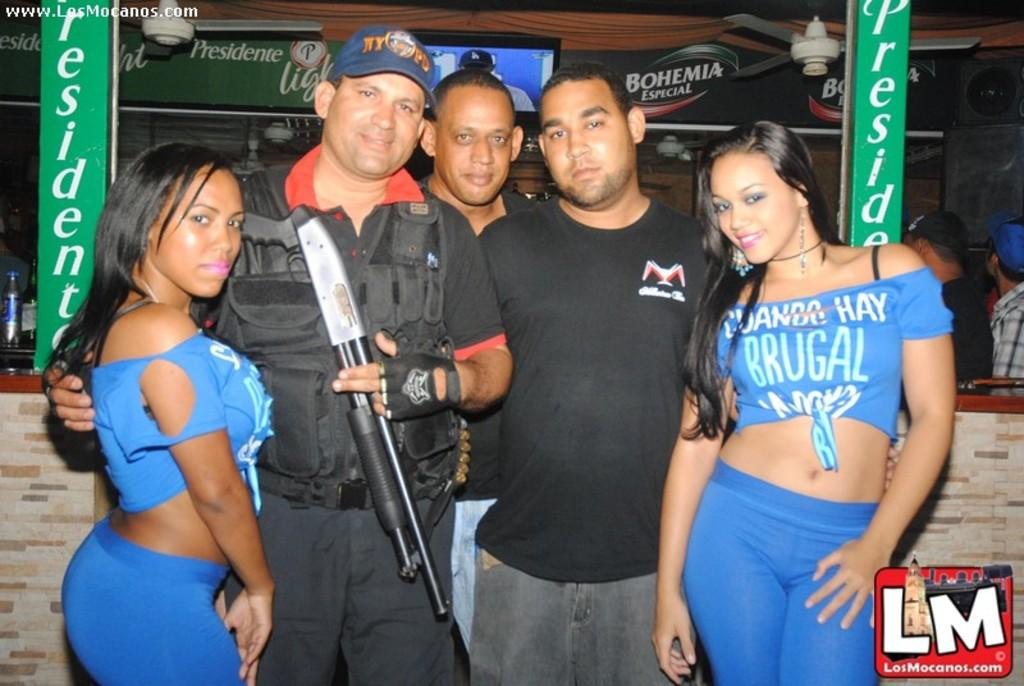How many people are present in the image? There are five people standing in the image. What is one of the men holding? One man is holding an object. What can be seen in the background of the image? There are hoardings, people, a bottle, a speaker, and fans in the background of the image. Are there any watermarks in the image? Yes, there are watermarks in the corner of the image. What type of industry is being represented in the image? There is no specific industry represented in the image; it simply shows five people standing with various objects and elements in the background. 